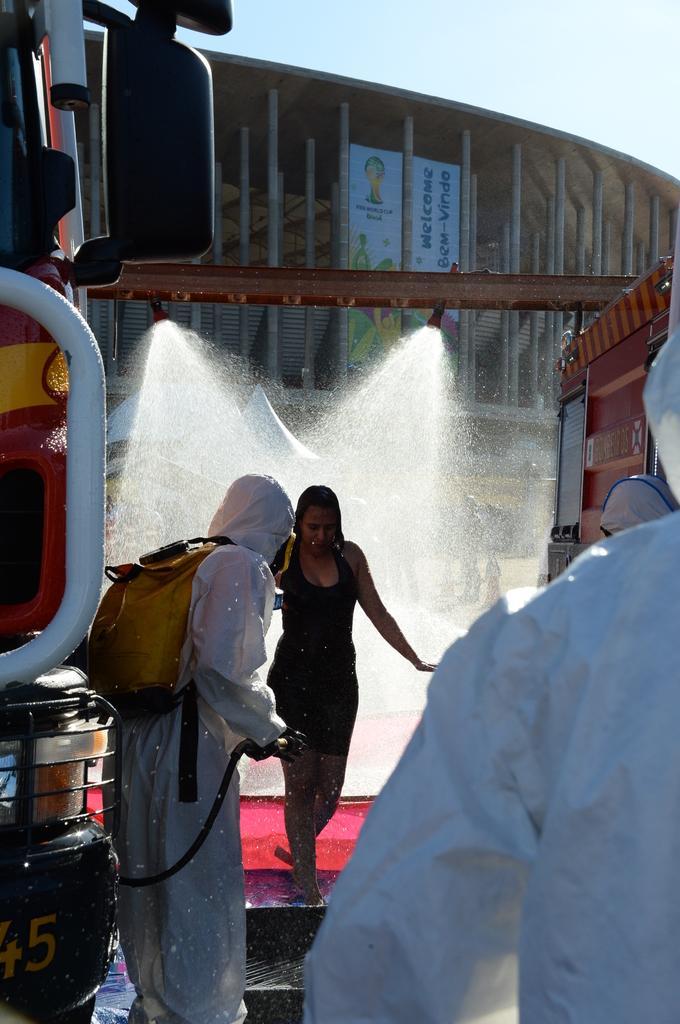In one or two sentences, can you explain what this image depicts? In this picture we can see group of people, in front of them we can see water and a building, and also we can see few vehicles. 